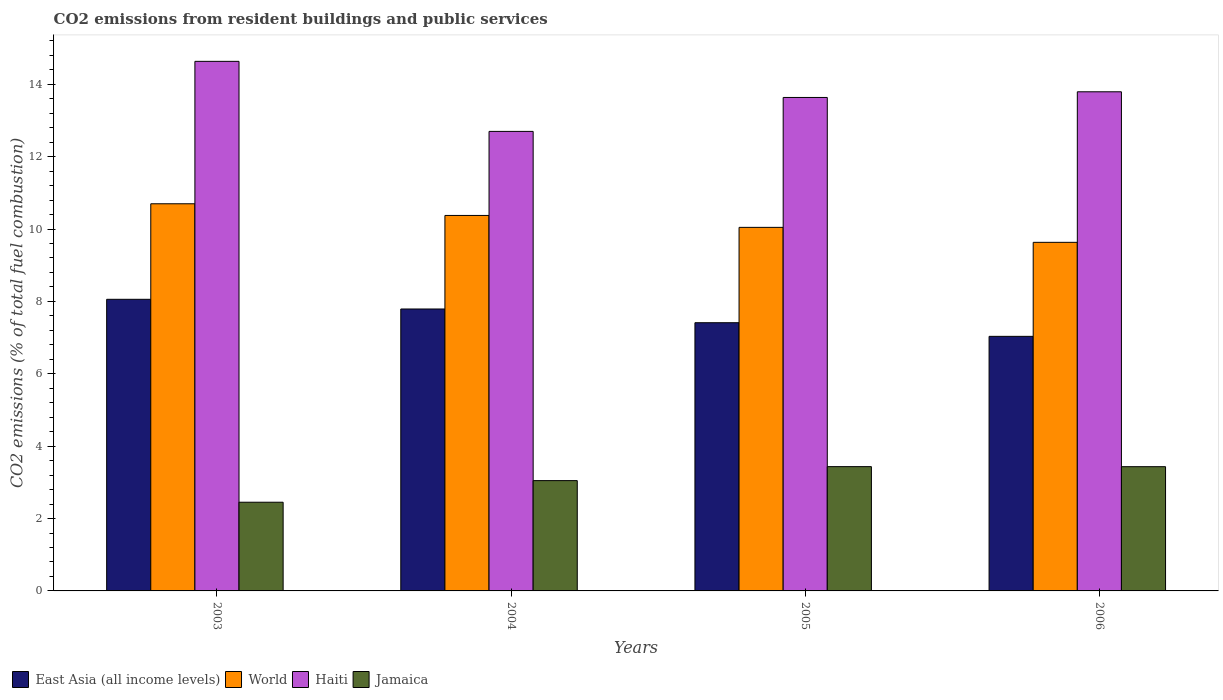How many groups of bars are there?
Your response must be concise. 4. Are the number of bars per tick equal to the number of legend labels?
Make the answer very short. Yes. Are the number of bars on each tick of the X-axis equal?
Provide a short and direct response. Yes. How many bars are there on the 2nd tick from the left?
Offer a very short reply. 4. In how many cases, is the number of bars for a given year not equal to the number of legend labels?
Give a very brief answer. 0. What is the total CO2 emitted in Jamaica in 2004?
Give a very brief answer. 3.05. Across all years, what is the maximum total CO2 emitted in Haiti?
Give a very brief answer. 14.63. Across all years, what is the minimum total CO2 emitted in East Asia (all income levels)?
Your answer should be very brief. 7.03. In which year was the total CO2 emitted in World minimum?
Provide a short and direct response. 2006. What is the total total CO2 emitted in East Asia (all income levels) in the graph?
Keep it short and to the point. 30.3. What is the difference between the total CO2 emitted in World in 2004 and that in 2005?
Offer a terse response. 0.33. What is the difference between the total CO2 emitted in World in 2003 and the total CO2 emitted in Haiti in 2006?
Give a very brief answer. -3.09. What is the average total CO2 emitted in Jamaica per year?
Ensure brevity in your answer.  3.09. In the year 2006, what is the difference between the total CO2 emitted in East Asia (all income levels) and total CO2 emitted in World?
Provide a short and direct response. -2.6. What is the ratio of the total CO2 emitted in Haiti in 2004 to that in 2006?
Give a very brief answer. 0.92. Is the total CO2 emitted in Jamaica in 2003 less than that in 2005?
Your answer should be compact. Yes. What is the difference between the highest and the second highest total CO2 emitted in World?
Provide a short and direct response. 0.32. What is the difference between the highest and the lowest total CO2 emitted in World?
Your answer should be very brief. 1.07. In how many years, is the total CO2 emitted in Haiti greater than the average total CO2 emitted in Haiti taken over all years?
Offer a terse response. 2. What does the 1st bar from the left in 2006 represents?
Offer a very short reply. East Asia (all income levels). What does the 1st bar from the right in 2003 represents?
Give a very brief answer. Jamaica. Is it the case that in every year, the sum of the total CO2 emitted in Haiti and total CO2 emitted in Jamaica is greater than the total CO2 emitted in World?
Offer a very short reply. Yes. What is the difference between two consecutive major ticks on the Y-axis?
Offer a terse response. 2. Are the values on the major ticks of Y-axis written in scientific E-notation?
Your answer should be very brief. No. Does the graph contain any zero values?
Keep it short and to the point. No. Where does the legend appear in the graph?
Offer a terse response. Bottom left. How many legend labels are there?
Offer a very short reply. 4. What is the title of the graph?
Ensure brevity in your answer.  CO2 emissions from resident buildings and public services. Does "Botswana" appear as one of the legend labels in the graph?
Your answer should be compact. No. What is the label or title of the X-axis?
Offer a very short reply. Years. What is the label or title of the Y-axis?
Keep it short and to the point. CO2 emissions (% of total fuel combustion). What is the CO2 emissions (% of total fuel combustion) in East Asia (all income levels) in 2003?
Ensure brevity in your answer.  8.06. What is the CO2 emissions (% of total fuel combustion) of World in 2003?
Keep it short and to the point. 10.7. What is the CO2 emissions (% of total fuel combustion) in Haiti in 2003?
Your answer should be compact. 14.63. What is the CO2 emissions (% of total fuel combustion) of Jamaica in 2003?
Offer a terse response. 2.45. What is the CO2 emissions (% of total fuel combustion) in East Asia (all income levels) in 2004?
Provide a short and direct response. 7.79. What is the CO2 emissions (% of total fuel combustion) of World in 2004?
Your response must be concise. 10.38. What is the CO2 emissions (% of total fuel combustion) of Haiti in 2004?
Offer a terse response. 12.7. What is the CO2 emissions (% of total fuel combustion) of Jamaica in 2004?
Your answer should be compact. 3.05. What is the CO2 emissions (% of total fuel combustion) of East Asia (all income levels) in 2005?
Your response must be concise. 7.41. What is the CO2 emissions (% of total fuel combustion) of World in 2005?
Your response must be concise. 10.05. What is the CO2 emissions (% of total fuel combustion) in Haiti in 2005?
Offer a very short reply. 13.64. What is the CO2 emissions (% of total fuel combustion) of Jamaica in 2005?
Keep it short and to the point. 3.43. What is the CO2 emissions (% of total fuel combustion) in East Asia (all income levels) in 2006?
Your answer should be compact. 7.03. What is the CO2 emissions (% of total fuel combustion) of World in 2006?
Provide a succinct answer. 9.63. What is the CO2 emissions (% of total fuel combustion) in Haiti in 2006?
Your answer should be very brief. 13.79. What is the CO2 emissions (% of total fuel combustion) of Jamaica in 2006?
Offer a terse response. 3.43. Across all years, what is the maximum CO2 emissions (% of total fuel combustion) of East Asia (all income levels)?
Keep it short and to the point. 8.06. Across all years, what is the maximum CO2 emissions (% of total fuel combustion) in World?
Give a very brief answer. 10.7. Across all years, what is the maximum CO2 emissions (% of total fuel combustion) in Haiti?
Your answer should be very brief. 14.63. Across all years, what is the maximum CO2 emissions (% of total fuel combustion) in Jamaica?
Your response must be concise. 3.43. Across all years, what is the minimum CO2 emissions (% of total fuel combustion) of East Asia (all income levels)?
Keep it short and to the point. 7.03. Across all years, what is the minimum CO2 emissions (% of total fuel combustion) of World?
Your answer should be very brief. 9.63. Across all years, what is the minimum CO2 emissions (% of total fuel combustion) of Haiti?
Provide a short and direct response. 12.7. Across all years, what is the minimum CO2 emissions (% of total fuel combustion) of Jamaica?
Offer a very short reply. 2.45. What is the total CO2 emissions (% of total fuel combustion) of East Asia (all income levels) in the graph?
Offer a very short reply. 30.3. What is the total CO2 emissions (% of total fuel combustion) of World in the graph?
Your answer should be compact. 40.75. What is the total CO2 emissions (% of total fuel combustion) in Haiti in the graph?
Your answer should be very brief. 54.76. What is the total CO2 emissions (% of total fuel combustion) of Jamaica in the graph?
Your response must be concise. 12.37. What is the difference between the CO2 emissions (% of total fuel combustion) of East Asia (all income levels) in 2003 and that in 2004?
Make the answer very short. 0.27. What is the difference between the CO2 emissions (% of total fuel combustion) of World in 2003 and that in 2004?
Your response must be concise. 0.32. What is the difference between the CO2 emissions (% of total fuel combustion) in Haiti in 2003 and that in 2004?
Offer a very short reply. 1.94. What is the difference between the CO2 emissions (% of total fuel combustion) of Jamaica in 2003 and that in 2004?
Keep it short and to the point. -0.6. What is the difference between the CO2 emissions (% of total fuel combustion) of East Asia (all income levels) in 2003 and that in 2005?
Your answer should be compact. 0.65. What is the difference between the CO2 emissions (% of total fuel combustion) of World in 2003 and that in 2005?
Make the answer very short. 0.65. What is the difference between the CO2 emissions (% of total fuel combustion) in Haiti in 2003 and that in 2005?
Your answer should be compact. 1. What is the difference between the CO2 emissions (% of total fuel combustion) in Jamaica in 2003 and that in 2005?
Offer a terse response. -0.98. What is the difference between the CO2 emissions (% of total fuel combustion) of East Asia (all income levels) in 2003 and that in 2006?
Your answer should be compact. 1.02. What is the difference between the CO2 emissions (% of total fuel combustion) of World in 2003 and that in 2006?
Offer a very short reply. 1.07. What is the difference between the CO2 emissions (% of total fuel combustion) of Haiti in 2003 and that in 2006?
Your answer should be compact. 0.84. What is the difference between the CO2 emissions (% of total fuel combustion) of Jamaica in 2003 and that in 2006?
Ensure brevity in your answer.  -0.98. What is the difference between the CO2 emissions (% of total fuel combustion) of East Asia (all income levels) in 2004 and that in 2005?
Your answer should be compact. 0.38. What is the difference between the CO2 emissions (% of total fuel combustion) in World in 2004 and that in 2005?
Your answer should be very brief. 0.33. What is the difference between the CO2 emissions (% of total fuel combustion) in Haiti in 2004 and that in 2005?
Give a very brief answer. -0.94. What is the difference between the CO2 emissions (% of total fuel combustion) in Jamaica in 2004 and that in 2005?
Give a very brief answer. -0.39. What is the difference between the CO2 emissions (% of total fuel combustion) of East Asia (all income levels) in 2004 and that in 2006?
Keep it short and to the point. 0.76. What is the difference between the CO2 emissions (% of total fuel combustion) in World in 2004 and that in 2006?
Offer a terse response. 0.74. What is the difference between the CO2 emissions (% of total fuel combustion) of Haiti in 2004 and that in 2006?
Make the answer very short. -1.09. What is the difference between the CO2 emissions (% of total fuel combustion) of Jamaica in 2004 and that in 2006?
Keep it short and to the point. -0.39. What is the difference between the CO2 emissions (% of total fuel combustion) in East Asia (all income levels) in 2005 and that in 2006?
Offer a very short reply. 0.38. What is the difference between the CO2 emissions (% of total fuel combustion) of World in 2005 and that in 2006?
Your answer should be very brief. 0.41. What is the difference between the CO2 emissions (% of total fuel combustion) in Haiti in 2005 and that in 2006?
Provide a short and direct response. -0.16. What is the difference between the CO2 emissions (% of total fuel combustion) of Jamaica in 2005 and that in 2006?
Your response must be concise. 0. What is the difference between the CO2 emissions (% of total fuel combustion) of East Asia (all income levels) in 2003 and the CO2 emissions (% of total fuel combustion) of World in 2004?
Provide a succinct answer. -2.32. What is the difference between the CO2 emissions (% of total fuel combustion) in East Asia (all income levels) in 2003 and the CO2 emissions (% of total fuel combustion) in Haiti in 2004?
Your answer should be very brief. -4.64. What is the difference between the CO2 emissions (% of total fuel combustion) in East Asia (all income levels) in 2003 and the CO2 emissions (% of total fuel combustion) in Jamaica in 2004?
Make the answer very short. 5.01. What is the difference between the CO2 emissions (% of total fuel combustion) in World in 2003 and the CO2 emissions (% of total fuel combustion) in Haiti in 2004?
Give a very brief answer. -2. What is the difference between the CO2 emissions (% of total fuel combustion) of World in 2003 and the CO2 emissions (% of total fuel combustion) of Jamaica in 2004?
Keep it short and to the point. 7.65. What is the difference between the CO2 emissions (% of total fuel combustion) in Haiti in 2003 and the CO2 emissions (% of total fuel combustion) in Jamaica in 2004?
Your answer should be compact. 11.59. What is the difference between the CO2 emissions (% of total fuel combustion) in East Asia (all income levels) in 2003 and the CO2 emissions (% of total fuel combustion) in World in 2005?
Ensure brevity in your answer.  -1.99. What is the difference between the CO2 emissions (% of total fuel combustion) of East Asia (all income levels) in 2003 and the CO2 emissions (% of total fuel combustion) of Haiti in 2005?
Make the answer very short. -5.58. What is the difference between the CO2 emissions (% of total fuel combustion) in East Asia (all income levels) in 2003 and the CO2 emissions (% of total fuel combustion) in Jamaica in 2005?
Provide a succinct answer. 4.62. What is the difference between the CO2 emissions (% of total fuel combustion) in World in 2003 and the CO2 emissions (% of total fuel combustion) in Haiti in 2005?
Your response must be concise. -2.94. What is the difference between the CO2 emissions (% of total fuel combustion) in World in 2003 and the CO2 emissions (% of total fuel combustion) in Jamaica in 2005?
Offer a terse response. 7.26. What is the difference between the CO2 emissions (% of total fuel combustion) of Haiti in 2003 and the CO2 emissions (% of total fuel combustion) of Jamaica in 2005?
Provide a short and direct response. 11.2. What is the difference between the CO2 emissions (% of total fuel combustion) in East Asia (all income levels) in 2003 and the CO2 emissions (% of total fuel combustion) in World in 2006?
Provide a short and direct response. -1.57. What is the difference between the CO2 emissions (% of total fuel combustion) in East Asia (all income levels) in 2003 and the CO2 emissions (% of total fuel combustion) in Haiti in 2006?
Give a very brief answer. -5.73. What is the difference between the CO2 emissions (% of total fuel combustion) of East Asia (all income levels) in 2003 and the CO2 emissions (% of total fuel combustion) of Jamaica in 2006?
Ensure brevity in your answer.  4.62. What is the difference between the CO2 emissions (% of total fuel combustion) in World in 2003 and the CO2 emissions (% of total fuel combustion) in Haiti in 2006?
Keep it short and to the point. -3.09. What is the difference between the CO2 emissions (% of total fuel combustion) in World in 2003 and the CO2 emissions (% of total fuel combustion) in Jamaica in 2006?
Offer a terse response. 7.27. What is the difference between the CO2 emissions (% of total fuel combustion) of Haiti in 2003 and the CO2 emissions (% of total fuel combustion) of Jamaica in 2006?
Provide a succinct answer. 11.2. What is the difference between the CO2 emissions (% of total fuel combustion) of East Asia (all income levels) in 2004 and the CO2 emissions (% of total fuel combustion) of World in 2005?
Keep it short and to the point. -2.26. What is the difference between the CO2 emissions (% of total fuel combustion) of East Asia (all income levels) in 2004 and the CO2 emissions (% of total fuel combustion) of Haiti in 2005?
Offer a very short reply. -5.85. What is the difference between the CO2 emissions (% of total fuel combustion) in East Asia (all income levels) in 2004 and the CO2 emissions (% of total fuel combustion) in Jamaica in 2005?
Ensure brevity in your answer.  4.36. What is the difference between the CO2 emissions (% of total fuel combustion) in World in 2004 and the CO2 emissions (% of total fuel combustion) in Haiti in 2005?
Your answer should be compact. -3.26. What is the difference between the CO2 emissions (% of total fuel combustion) in World in 2004 and the CO2 emissions (% of total fuel combustion) in Jamaica in 2005?
Make the answer very short. 6.94. What is the difference between the CO2 emissions (% of total fuel combustion) in Haiti in 2004 and the CO2 emissions (% of total fuel combustion) in Jamaica in 2005?
Provide a short and direct response. 9.26. What is the difference between the CO2 emissions (% of total fuel combustion) of East Asia (all income levels) in 2004 and the CO2 emissions (% of total fuel combustion) of World in 2006?
Your response must be concise. -1.84. What is the difference between the CO2 emissions (% of total fuel combustion) in East Asia (all income levels) in 2004 and the CO2 emissions (% of total fuel combustion) in Haiti in 2006?
Ensure brevity in your answer.  -6. What is the difference between the CO2 emissions (% of total fuel combustion) of East Asia (all income levels) in 2004 and the CO2 emissions (% of total fuel combustion) of Jamaica in 2006?
Ensure brevity in your answer.  4.36. What is the difference between the CO2 emissions (% of total fuel combustion) in World in 2004 and the CO2 emissions (% of total fuel combustion) in Haiti in 2006?
Make the answer very short. -3.42. What is the difference between the CO2 emissions (% of total fuel combustion) in World in 2004 and the CO2 emissions (% of total fuel combustion) in Jamaica in 2006?
Offer a terse response. 6.94. What is the difference between the CO2 emissions (% of total fuel combustion) of Haiti in 2004 and the CO2 emissions (% of total fuel combustion) of Jamaica in 2006?
Provide a succinct answer. 9.26. What is the difference between the CO2 emissions (% of total fuel combustion) in East Asia (all income levels) in 2005 and the CO2 emissions (% of total fuel combustion) in World in 2006?
Provide a short and direct response. -2.22. What is the difference between the CO2 emissions (% of total fuel combustion) of East Asia (all income levels) in 2005 and the CO2 emissions (% of total fuel combustion) of Haiti in 2006?
Your answer should be compact. -6.38. What is the difference between the CO2 emissions (% of total fuel combustion) in East Asia (all income levels) in 2005 and the CO2 emissions (% of total fuel combustion) in Jamaica in 2006?
Offer a very short reply. 3.98. What is the difference between the CO2 emissions (% of total fuel combustion) of World in 2005 and the CO2 emissions (% of total fuel combustion) of Haiti in 2006?
Provide a short and direct response. -3.75. What is the difference between the CO2 emissions (% of total fuel combustion) in World in 2005 and the CO2 emissions (% of total fuel combustion) in Jamaica in 2006?
Your response must be concise. 6.61. What is the difference between the CO2 emissions (% of total fuel combustion) of Haiti in 2005 and the CO2 emissions (% of total fuel combustion) of Jamaica in 2006?
Offer a terse response. 10.2. What is the average CO2 emissions (% of total fuel combustion) in East Asia (all income levels) per year?
Make the answer very short. 7.57. What is the average CO2 emissions (% of total fuel combustion) in World per year?
Offer a terse response. 10.19. What is the average CO2 emissions (% of total fuel combustion) of Haiti per year?
Offer a very short reply. 13.69. What is the average CO2 emissions (% of total fuel combustion) in Jamaica per year?
Offer a terse response. 3.09. In the year 2003, what is the difference between the CO2 emissions (% of total fuel combustion) in East Asia (all income levels) and CO2 emissions (% of total fuel combustion) in World?
Your answer should be compact. -2.64. In the year 2003, what is the difference between the CO2 emissions (% of total fuel combustion) in East Asia (all income levels) and CO2 emissions (% of total fuel combustion) in Haiti?
Your answer should be compact. -6.58. In the year 2003, what is the difference between the CO2 emissions (% of total fuel combustion) in East Asia (all income levels) and CO2 emissions (% of total fuel combustion) in Jamaica?
Offer a very short reply. 5.61. In the year 2003, what is the difference between the CO2 emissions (% of total fuel combustion) of World and CO2 emissions (% of total fuel combustion) of Haiti?
Provide a short and direct response. -3.94. In the year 2003, what is the difference between the CO2 emissions (% of total fuel combustion) in World and CO2 emissions (% of total fuel combustion) in Jamaica?
Your answer should be very brief. 8.25. In the year 2003, what is the difference between the CO2 emissions (% of total fuel combustion) in Haiti and CO2 emissions (% of total fuel combustion) in Jamaica?
Your answer should be very brief. 12.18. In the year 2004, what is the difference between the CO2 emissions (% of total fuel combustion) of East Asia (all income levels) and CO2 emissions (% of total fuel combustion) of World?
Your answer should be very brief. -2.59. In the year 2004, what is the difference between the CO2 emissions (% of total fuel combustion) in East Asia (all income levels) and CO2 emissions (% of total fuel combustion) in Haiti?
Ensure brevity in your answer.  -4.91. In the year 2004, what is the difference between the CO2 emissions (% of total fuel combustion) in East Asia (all income levels) and CO2 emissions (% of total fuel combustion) in Jamaica?
Ensure brevity in your answer.  4.74. In the year 2004, what is the difference between the CO2 emissions (% of total fuel combustion) in World and CO2 emissions (% of total fuel combustion) in Haiti?
Ensure brevity in your answer.  -2.32. In the year 2004, what is the difference between the CO2 emissions (% of total fuel combustion) of World and CO2 emissions (% of total fuel combustion) of Jamaica?
Provide a short and direct response. 7.33. In the year 2004, what is the difference between the CO2 emissions (% of total fuel combustion) in Haiti and CO2 emissions (% of total fuel combustion) in Jamaica?
Offer a terse response. 9.65. In the year 2005, what is the difference between the CO2 emissions (% of total fuel combustion) of East Asia (all income levels) and CO2 emissions (% of total fuel combustion) of World?
Offer a very short reply. -2.63. In the year 2005, what is the difference between the CO2 emissions (% of total fuel combustion) of East Asia (all income levels) and CO2 emissions (% of total fuel combustion) of Haiti?
Keep it short and to the point. -6.22. In the year 2005, what is the difference between the CO2 emissions (% of total fuel combustion) of East Asia (all income levels) and CO2 emissions (% of total fuel combustion) of Jamaica?
Your response must be concise. 3.98. In the year 2005, what is the difference between the CO2 emissions (% of total fuel combustion) in World and CO2 emissions (% of total fuel combustion) in Haiti?
Offer a very short reply. -3.59. In the year 2005, what is the difference between the CO2 emissions (% of total fuel combustion) in World and CO2 emissions (% of total fuel combustion) in Jamaica?
Give a very brief answer. 6.61. In the year 2005, what is the difference between the CO2 emissions (% of total fuel combustion) in Haiti and CO2 emissions (% of total fuel combustion) in Jamaica?
Offer a very short reply. 10.2. In the year 2006, what is the difference between the CO2 emissions (% of total fuel combustion) in East Asia (all income levels) and CO2 emissions (% of total fuel combustion) in World?
Provide a short and direct response. -2.6. In the year 2006, what is the difference between the CO2 emissions (% of total fuel combustion) of East Asia (all income levels) and CO2 emissions (% of total fuel combustion) of Haiti?
Offer a terse response. -6.76. In the year 2006, what is the difference between the CO2 emissions (% of total fuel combustion) in East Asia (all income levels) and CO2 emissions (% of total fuel combustion) in Jamaica?
Your answer should be very brief. 3.6. In the year 2006, what is the difference between the CO2 emissions (% of total fuel combustion) of World and CO2 emissions (% of total fuel combustion) of Haiti?
Your response must be concise. -4.16. In the year 2006, what is the difference between the CO2 emissions (% of total fuel combustion) in World and CO2 emissions (% of total fuel combustion) in Jamaica?
Offer a very short reply. 6.2. In the year 2006, what is the difference between the CO2 emissions (% of total fuel combustion) in Haiti and CO2 emissions (% of total fuel combustion) in Jamaica?
Ensure brevity in your answer.  10.36. What is the ratio of the CO2 emissions (% of total fuel combustion) in East Asia (all income levels) in 2003 to that in 2004?
Your answer should be compact. 1.03. What is the ratio of the CO2 emissions (% of total fuel combustion) in World in 2003 to that in 2004?
Ensure brevity in your answer.  1.03. What is the ratio of the CO2 emissions (% of total fuel combustion) of Haiti in 2003 to that in 2004?
Keep it short and to the point. 1.15. What is the ratio of the CO2 emissions (% of total fuel combustion) of Jamaica in 2003 to that in 2004?
Provide a succinct answer. 0.8. What is the ratio of the CO2 emissions (% of total fuel combustion) of East Asia (all income levels) in 2003 to that in 2005?
Your answer should be very brief. 1.09. What is the ratio of the CO2 emissions (% of total fuel combustion) in World in 2003 to that in 2005?
Offer a very short reply. 1.06. What is the ratio of the CO2 emissions (% of total fuel combustion) of Haiti in 2003 to that in 2005?
Your answer should be very brief. 1.07. What is the ratio of the CO2 emissions (% of total fuel combustion) in Jamaica in 2003 to that in 2005?
Provide a succinct answer. 0.71. What is the ratio of the CO2 emissions (% of total fuel combustion) of East Asia (all income levels) in 2003 to that in 2006?
Provide a succinct answer. 1.15. What is the ratio of the CO2 emissions (% of total fuel combustion) of World in 2003 to that in 2006?
Make the answer very short. 1.11. What is the ratio of the CO2 emissions (% of total fuel combustion) of Haiti in 2003 to that in 2006?
Your answer should be very brief. 1.06. What is the ratio of the CO2 emissions (% of total fuel combustion) in Jamaica in 2003 to that in 2006?
Your response must be concise. 0.71. What is the ratio of the CO2 emissions (% of total fuel combustion) in East Asia (all income levels) in 2004 to that in 2005?
Provide a succinct answer. 1.05. What is the ratio of the CO2 emissions (% of total fuel combustion) in World in 2004 to that in 2005?
Offer a very short reply. 1.03. What is the ratio of the CO2 emissions (% of total fuel combustion) of Haiti in 2004 to that in 2005?
Make the answer very short. 0.93. What is the ratio of the CO2 emissions (% of total fuel combustion) of Jamaica in 2004 to that in 2005?
Offer a terse response. 0.89. What is the ratio of the CO2 emissions (% of total fuel combustion) of East Asia (all income levels) in 2004 to that in 2006?
Keep it short and to the point. 1.11. What is the ratio of the CO2 emissions (% of total fuel combustion) of World in 2004 to that in 2006?
Ensure brevity in your answer.  1.08. What is the ratio of the CO2 emissions (% of total fuel combustion) of Haiti in 2004 to that in 2006?
Provide a succinct answer. 0.92. What is the ratio of the CO2 emissions (% of total fuel combustion) of Jamaica in 2004 to that in 2006?
Give a very brief answer. 0.89. What is the ratio of the CO2 emissions (% of total fuel combustion) of East Asia (all income levels) in 2005 to that in 2006?
Make the answer very short. 1.05. What is the ratio of the CO2 emissions (% of total fuel combustion) of World in 2005 to that in 2006?
Your answer should be very brief. 1.04. What is the ratio of the CO2 emissions (% of total fuel combustion) in Haiti in 2005 to that in 2006?
Keep it short and to the point. 0.99. What is the ratio of the CO2 emissions (% of total fuel combustion) of Jamaica in 2005 to that in 2006?
Ensure brevity in your answer.  1. What is the difference between the highest and the second highest CO2 emissions (% of total fuel combustion) of East Asia (all income levels)?
Ensure brevity in your answer.  0.27. What is the difference between the highest and the second highest CO2 emissions (% of total fuel combustion) in World?
Your answer should be very brief. 0.32. What is the difference between the highest and the second highest CO2 emissions (% of total fuel combustion) in Haiti?
Offer a very short reply. 0.84. What is the difference between the highest and the second highest CO2 emissions (% of total fuel combustion) of Jamaica?
Keep it short and to the point. 0. What is the difference between the highest and the lowest CO2 emissions (% of total fuel combustion) in East Asia (all income levels)?
Make the answer very short. 1.02. What is the difference between the highest and the lowest CO2 emissions (% of total fuel combustion) in World?
Offer a terse response. 1.07. What is the difference between the highest and the lowest CO2 emissions (% of total fuel combustion) in Haiti?
Your response must be concise. 1.94. What is the difference between the highest and the lowest CO2 emissions (% of total fuel combustion) of Jamaica?
Your answer should be compact. 0.98. 